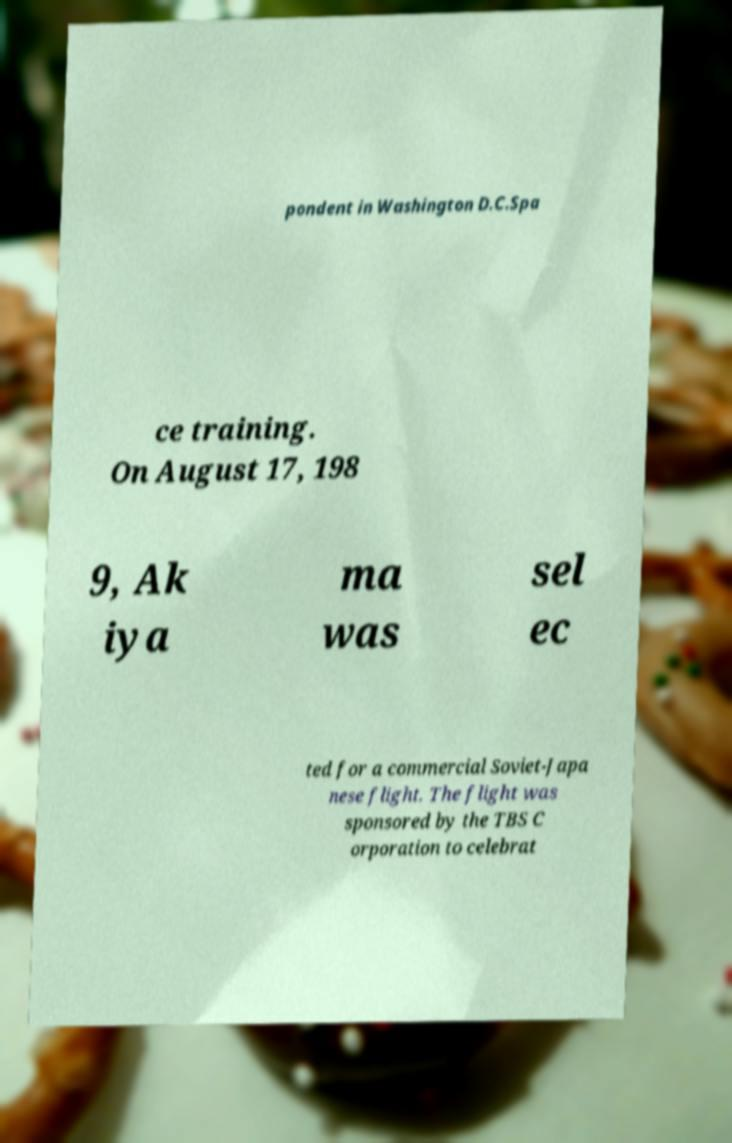I need the written content from this picture converted into text. Can you do that? pondent in Washington D.C.Spa ce training. On August 17, 198 9, Ak iya ma was sel ec ted for a commercial Soviet-Japa nese flight. The flight was sponsored by the TBS C orporation to celebrat 